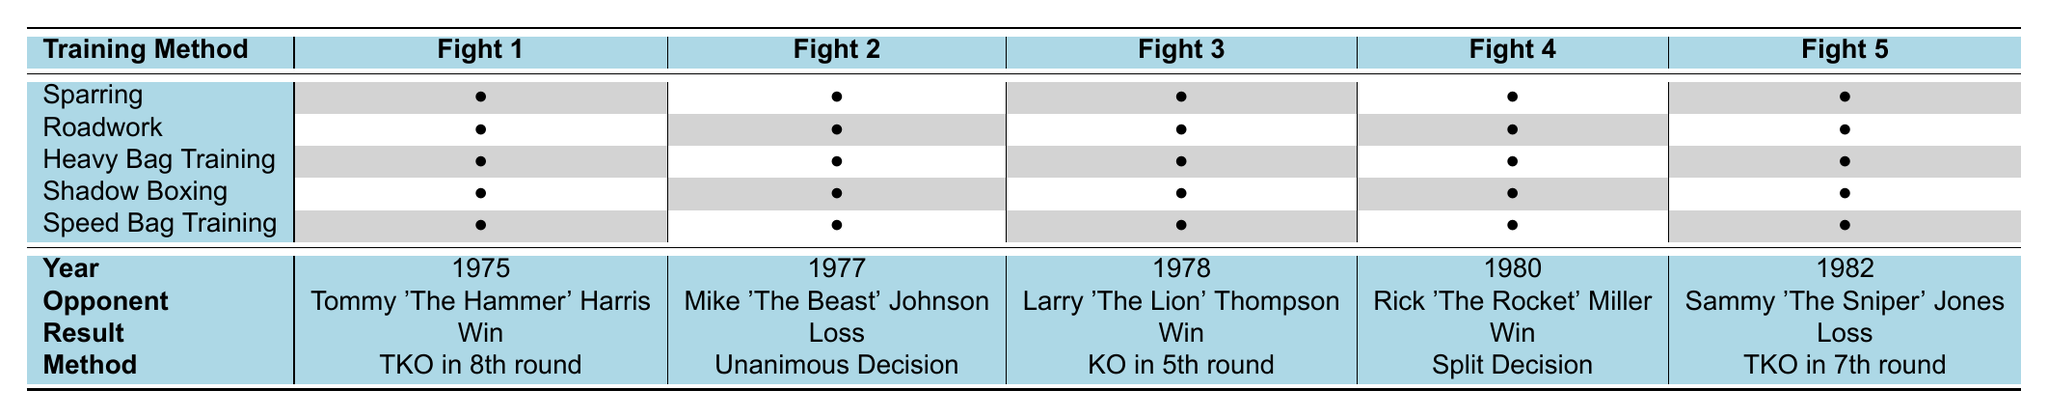What was the result of the fight against Tommy 'The Hammer' Harris? The table indicates that Tommy 'The Hammer' Harris was fought in 1975, and the result of that fight was a win.
Answer: Win How many fights resulted in a loss? Looking at the results column, there are two instances marked as "Loss": one against Mike 'The Beast' Johnson in 1977 and another against Sammy 'The Sniper' Jones in 1982. Thus, the total loss count is 2.
Answer: 2 Which training method was used in Fight 3? In the training method column for Fight 3, it lists all the training methods, and Heavy Bag Training, Speed Bag Training, Sparring, and Shadow Boxing have bullet points indicating they were used. Therefore, multiple methods were involved in Fight 3.
Answer: Heavy Bag Training, Speed Bag Training, Sparring, Shadow Boxing Was there a fight that ended with a Split Decision? Checking the "Method" column shows that Fight 4, against Rick 'The Rocket' Miller in 1980, was listed as a "Split Decision." So, the answer is yes.
Answer: Yes What training methods did Grandfather use in fights that he lost? The fights that resulted in a loss were Fight 2 and Fight 5. For Fight 2 (against Mike 'The Beast' Johnson), the training methods used were Sparring, Roadwork, Heavy Bag Training, Shadow Boxing, and Speed Bag Training. In Fight 5 (against Sammy 'The Sniper' Jones), the methods were Sparring, Roadwork, Heavy Bag Training, Shadow Boxing, and Speed Bag Training. Therefore, all training methods were used in both losses.
Answer: Sparring, Roadwork, Heavy Bag Training, Shadow Boxing, Speed Bag Training Which opponent did Grandfather beat with a KO? Referring to the results and methods, Fight 3 against Larry 'The Lion' Thompson in 1978 is indicated as a "Win" with a "KO in 5th round." Thus, Larry 'The Lion' Thompson is the opponent he beat with a KO.
Answer: Larry 'The Lion' Thompson How many times did Grandfather fight in the 1970s? The fights listed in the 1970s are Fight 1 (1975), Fight 2 (1977), and Fight 3 (1978). Therefore, a total of 3 fights occurred during that decade.
Answer: 3 What is the total number of fights Grandfather had? By counting the entries in the boxing fight history, we see there are five distinct fights listed (Fight 1 to Fight 5). Thus, the total number of fights is 5.
Answer: 5 In which year did Grandfather fight the opponent with the nickname "The Beast"? The opponent with the nickname "The Beast" is Mike 'The Beast' Johnson, who fought in 1977 according to the year listed next to his name.
Answer: 1977 